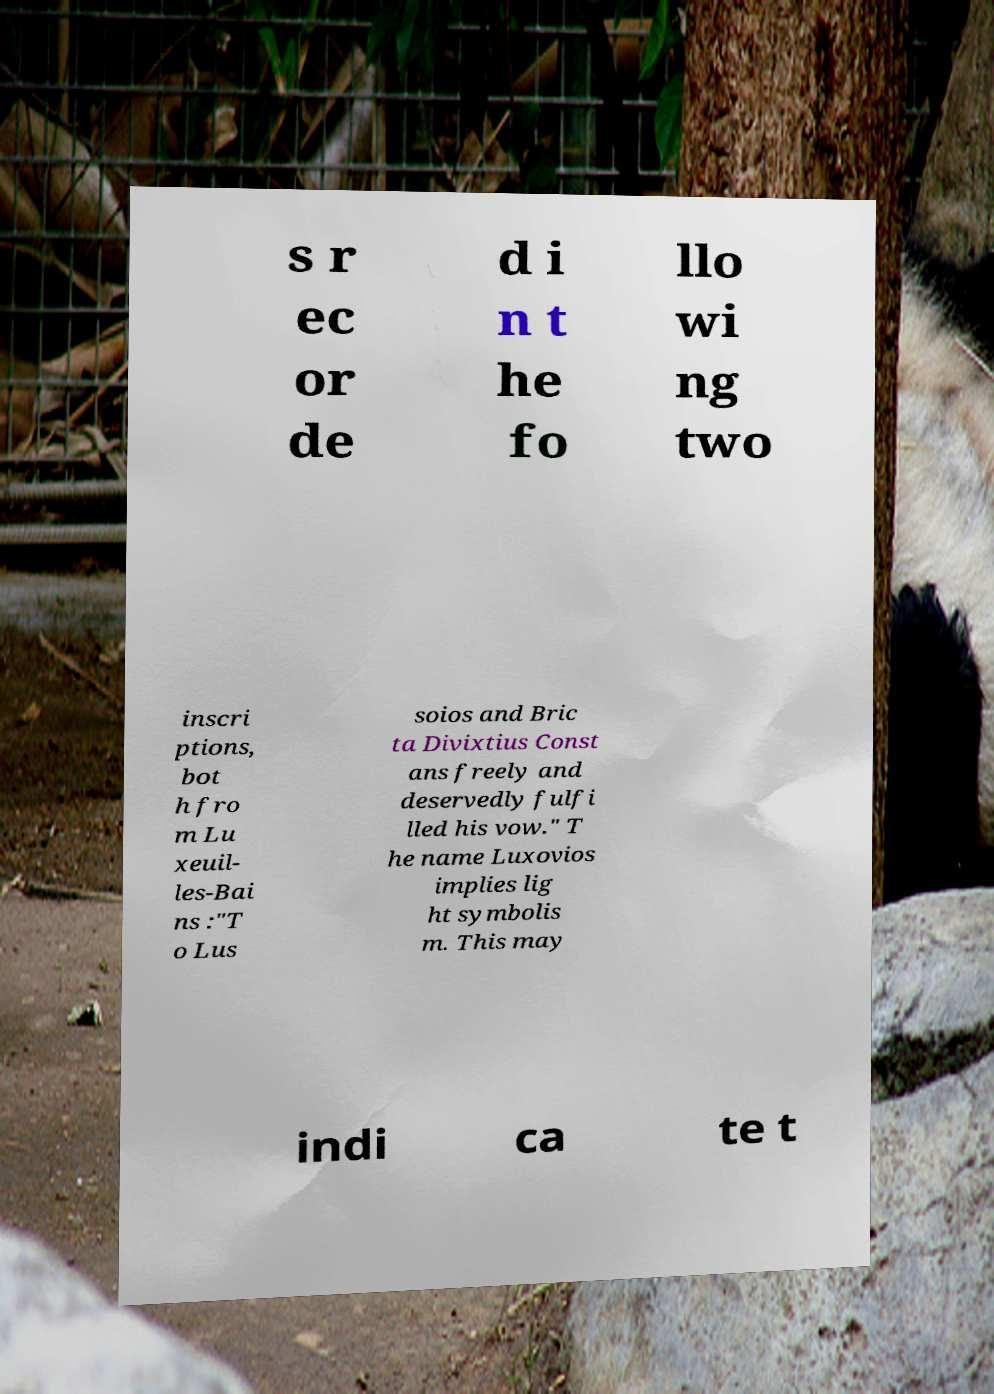I need the written content from this picture converted into text. Can you do that? s r ec or de d i n t he fo llo wi ng two inscri ptions, bot h fro m Lu xeuil- les-Bai ns :"T o Lus soios and Bric ta Divixtius Const ans freely and deservedly fulfi lled his vow." T he name Luxovios implies lig ht symbolis m. This may indi ca te t 